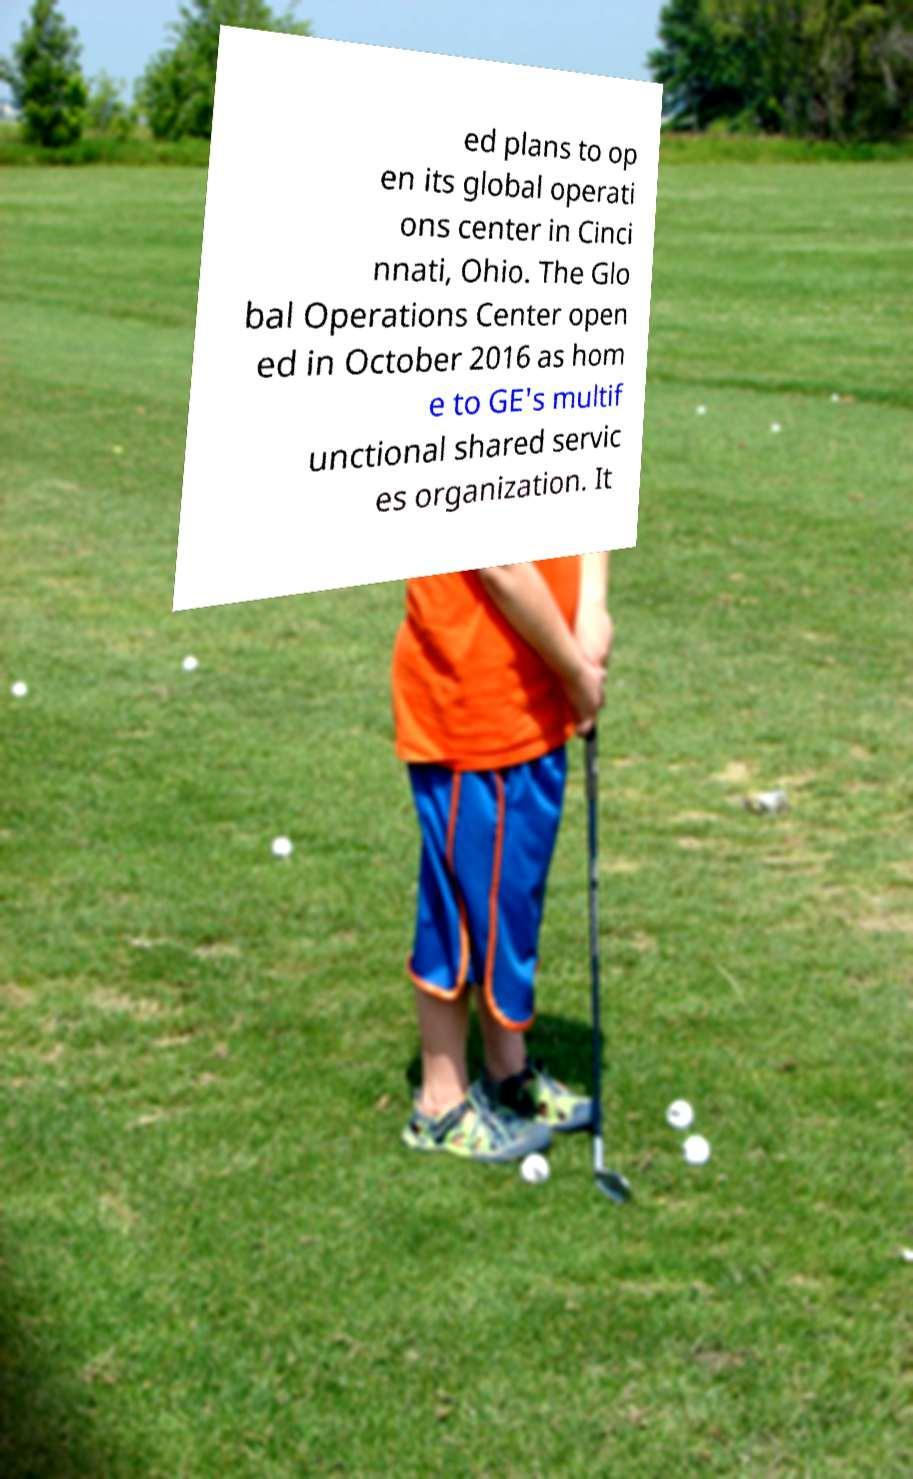Could you assist in decoding the text presented in this image and type it out clearly? ed plans to op en its global operati ons center in Cinci nnati, Ohio. The Glo bal Operations Center open ed in October 2016 as hom e to GE's multif unctional shared servic es organization. It 